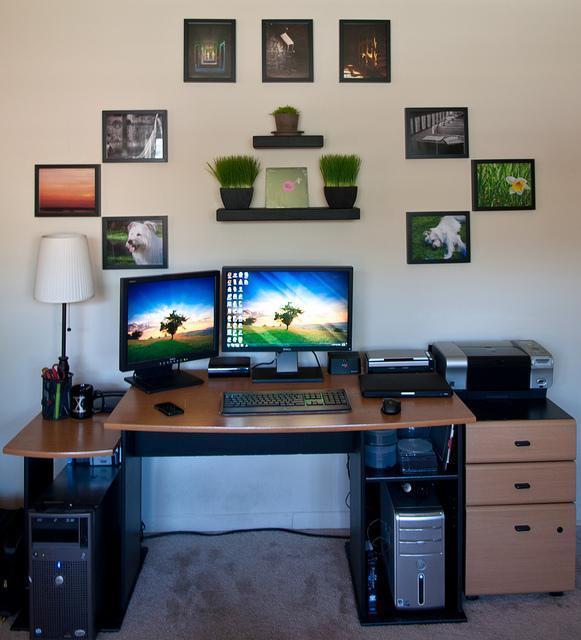How many pictures are on the wall?
Give a very brief answer. 9. How many screens does this computer have?
Give a very brief answer. 2. How many potted plants are in the photo?
Give a very brief answer. 1. How many tvs are in the photo?
Give a very brief answer. 2. 